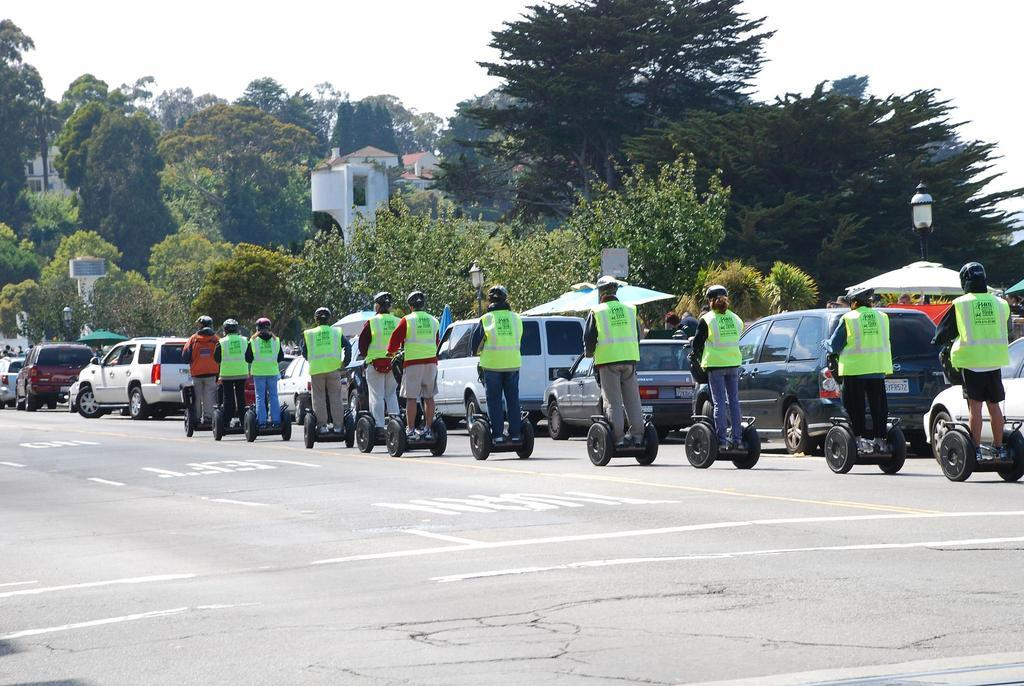What are the people in the image using to travel on the road? The people in the image are riding Segways on the road. What else can be seen on the road besides the Segways? There are vehicles on the road. What type of natural elements are visible in the image? There are trees visible in the image. What type of man-made structures can be seen in the image? There are buildings in the image. What is visible at the top of the image? The sky is visible at the top of the image. Where is the pail of honey being used in the image? There is no pail of honey present in the image. What type of cast is visible on the people riding Segways? There is no cast visible on the people riding Segways in the image. 